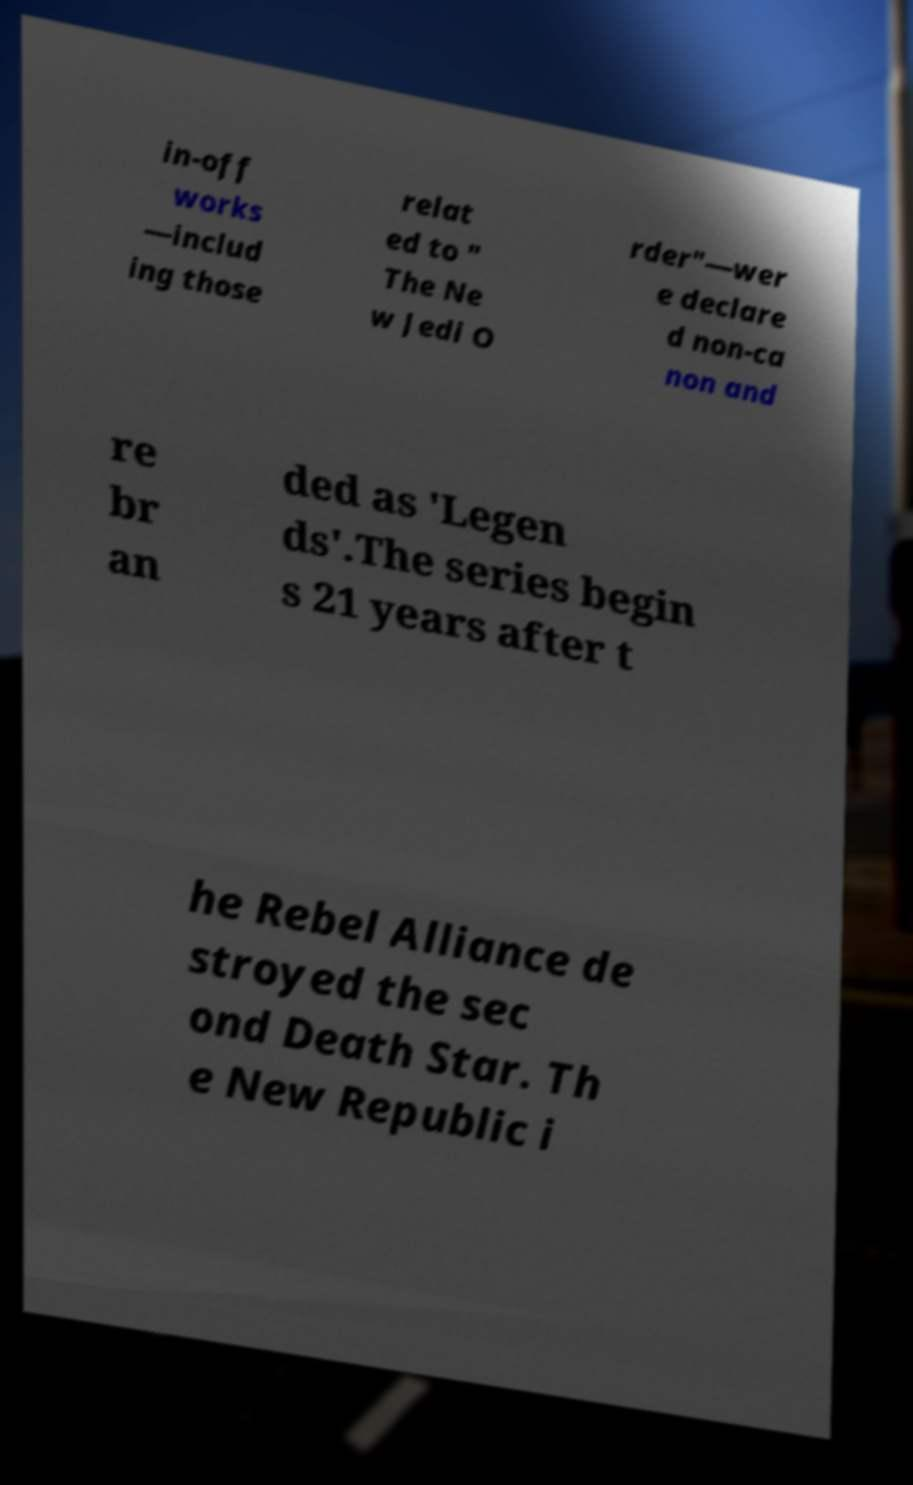Please identify and transcribe the text found in this image. in-off works —includ ing those relat ed to " The Ne w Jedi O rder"—wer e declare d non-ca non and re br an ded as 'Legen ds'.The series begin s 21 years after t he Rebel Alliance de stroyed the sec ond Death Star. Th e New Republic i 